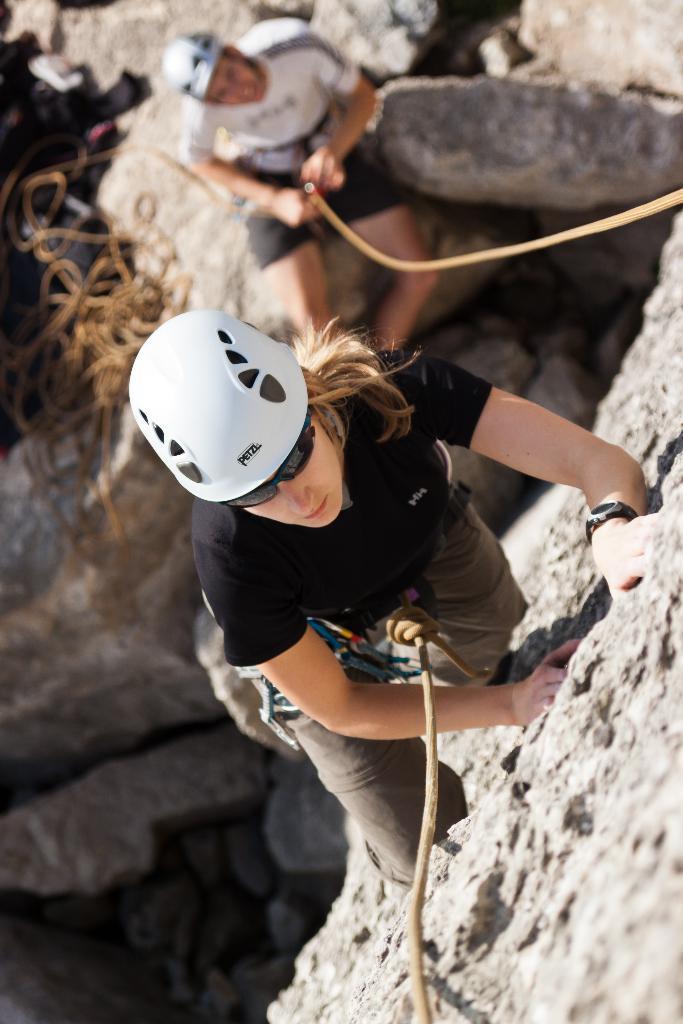Can you describe this image briefly? In this image in the center there is one woman who is climbing and she is wearing some belt, at the bottom there is one man who is sitting and he is holding a rope and there are some rocks. On the left side there are some ropes. 